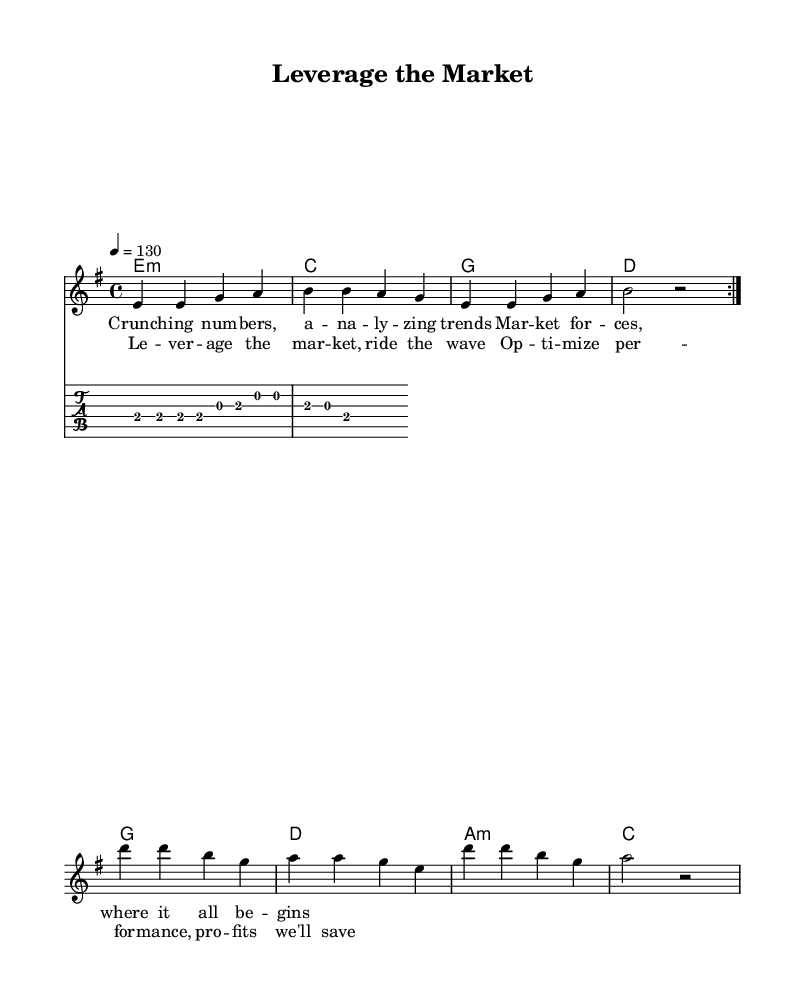What is the key signature of this music? The key signature is indicated by the 'key e minor' in the global settings of the score. E minor has one sharp (F#).
Answer: E minor What is the time signature of this music? The time signature is specified as '4/4' in the global settings of the score. This means there are four beats in a measure and a quarter note receives one beat.
Answer: 4/4 What is the tempo marking for this piece? The tempo is noted as '4 = 130', which indicates that there are 130 beats per minute for a quarter note. This corresponds to a moderate tempo.
Answer: 130 How many measures are in the melody section? The melody section has a repeated volta, which consists of 8 measures in total (4 measures for each volta repeated twice).
Answer: 8 What chord is played during the chorus? The chorus follows the chord scheme provided which includes E minor, C major, G major, D major, and A minor. The first chord in the chorus is E minor. Therefore, during the chorus, it starts on E minor.
Answer: E minor How does the verse lyrically relate to corporate strategy? The lyrics in the verse mention 'Crunching numbers' and 'Analyzing trends', which directly connect to corporate strategy and market analysis as they involve data interpretation and understanding market forces.
Answer: Data interpretation What is the significance of the term 'Leverage the market' in the context of the song? The phrase 'Leverage the market' in the chorus indicates a strategic approach to utilize market conditions to maximize profit, aligning closely with corporate strategy concepts like optimization and performance management.
Answer: Strategic approach 